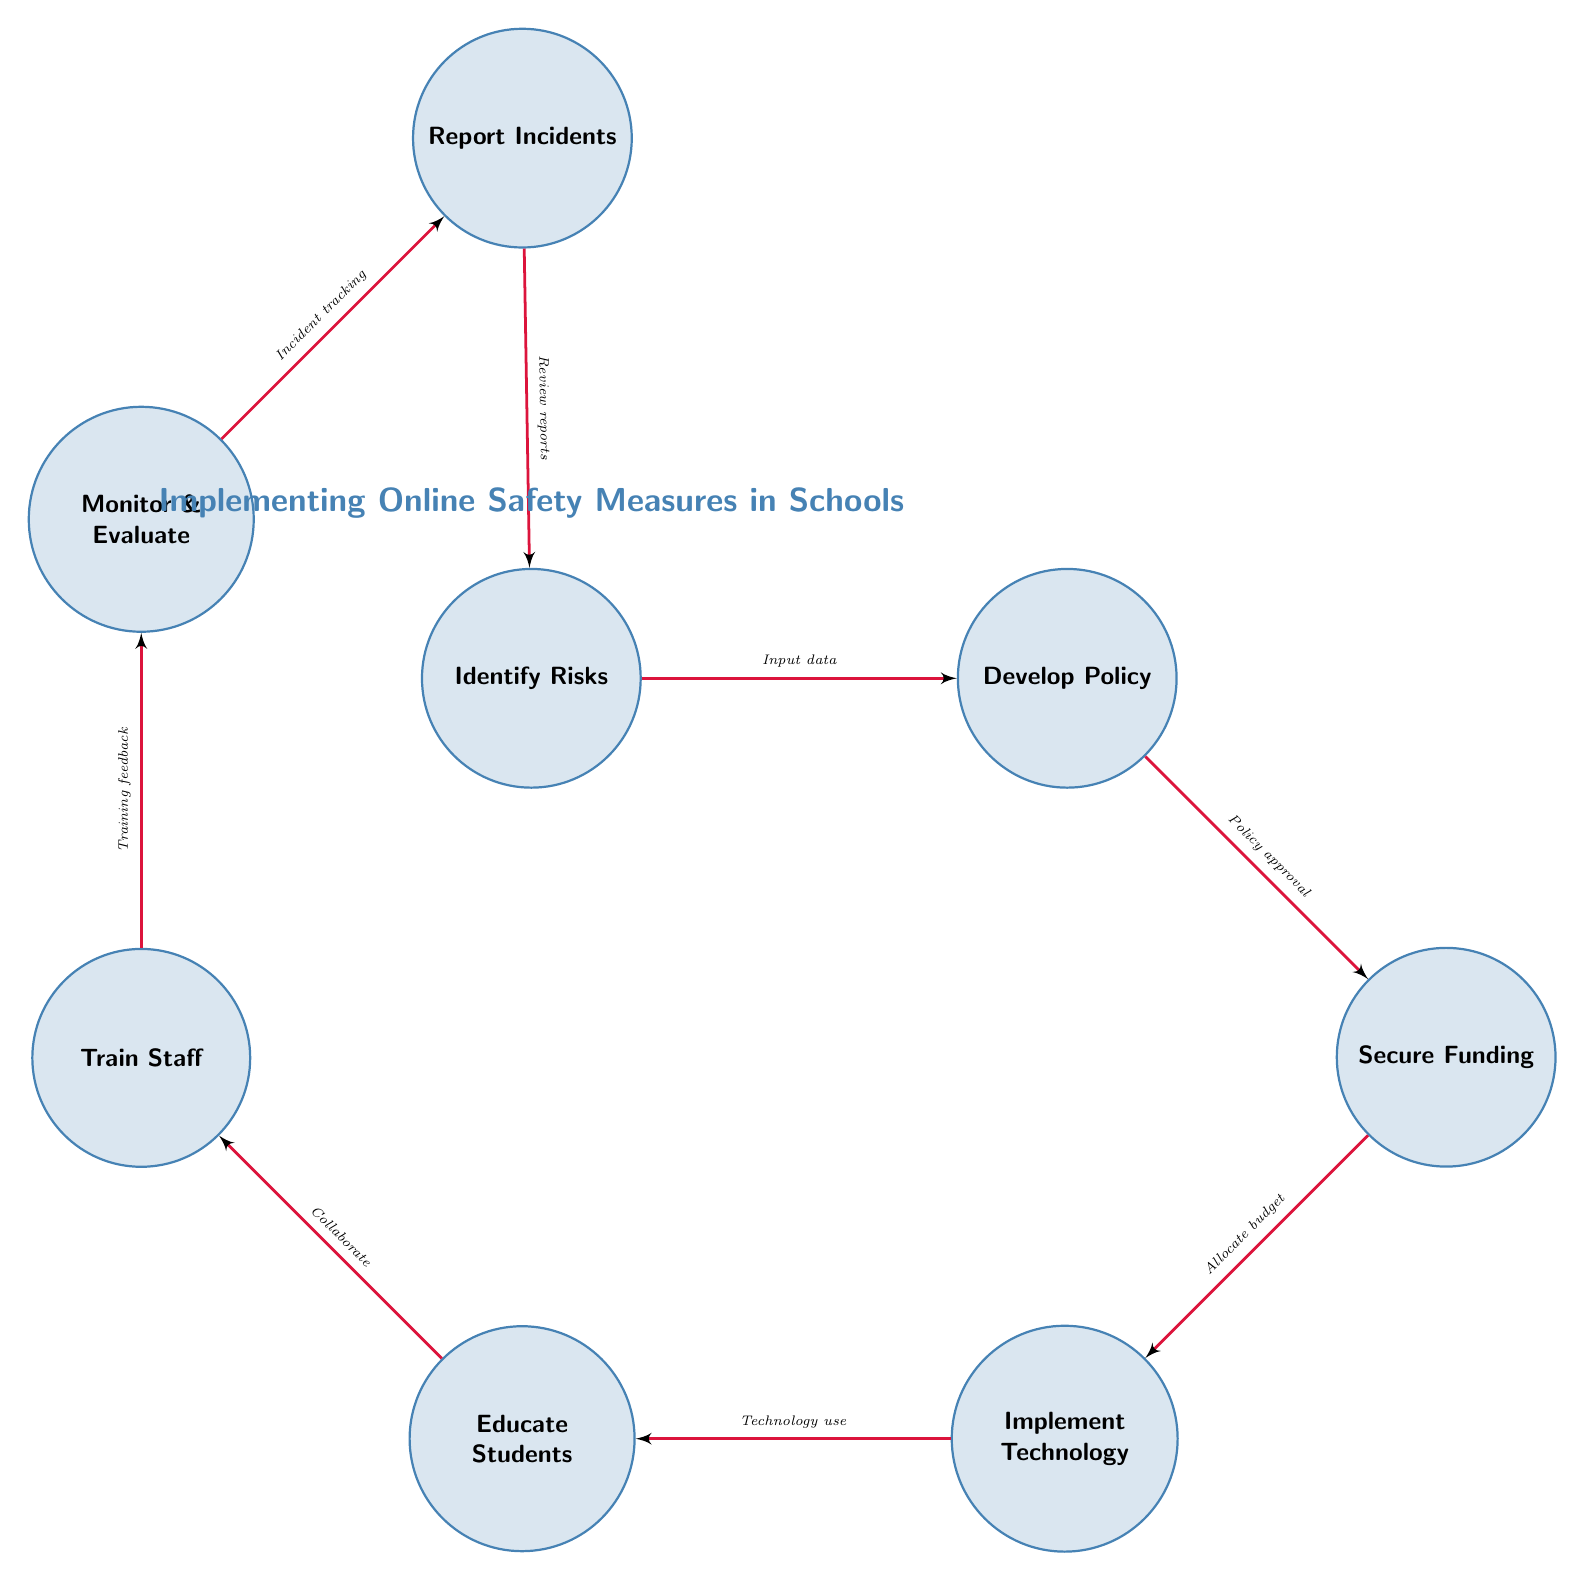What is the first step in the process? The first step in the process is labeled as "Identify Risks," which is the starting point of the diagram and represents assessing potential online threats to children in schools.
Answer: Identify Risks How many nodes are in the diagram? There are a total of eight nodes in the diagram, each representing a specific stage in the implementation of online safety measures in schools.
Answer: 8 What connects "Develop Policy" and "Secure Funding"? "Develop Policy" is connected to "Secure Funding" through a directed edge labeled "Policy approval," indicating that after the policy formulation, budget allocation is necessary.
Answer: Policy approval What is the last step before monitoring and evaluating? The last step before monitoring and evaluating is "Train Staff," which involves providing training to teachers and administrators to effectively implement safety measures.
Answer: Train Staff How does the process flow from "Educate Students"? From "Educate Students," the process flows to "Train Staff" through a directed edge labeled "Collaborate," suggesting that collaboration between students' education and staff training is essential for successful implementation.
Answer: Train Staff What is the purpose of "Report Incidents"? The purpose of "Report Incidents" is to establish a system for reporting online safety breaches, completed after monitoring and evaluating the safety measures.
Answer: Establish a system for reporting online safety breaches Which node follows "Secure Funding"? "Implement Technology" follows "Secure Funding" as the next step, indicating that financial resources must be secured before technology can be deployed.
Answer: Implement Technology What feedback is collected in the monitoring stage? In the monitoring stage, "Training feedback" is collected, which provides insights into the effectiveness of the staff training and implementation of safety measures.
Answer: Training feedback How does the cycle restart after "Report Incidents"? After "Report Incidents," the cycle restarts back to "Identify Risks" through a directed edge labeled "Review reports," indicating that incidents lead to reassessing potential risks.
Answer: Review reports 